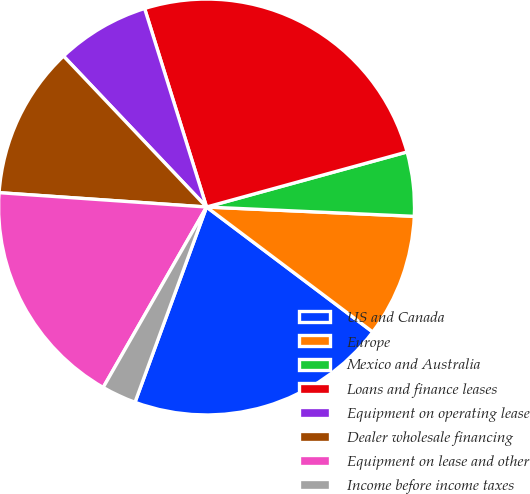Convert chart to OTSL. <chart><loc_0><loc_0><loc_500><loc_500><pie_chart><fcel>US and Canada<fcel>Europe<fcel>Mexico and Australia<fcel>Loans and finance leases<fcel>Equipment on operating lease<fcel>Dealer wholesale financing<fcel>Equipment on lease and other<fcel>Income before income taxes<nl><fcel>20.33%<fcel>9.55%<fcel>4.98%<fcel>25.55%<fcel>7.26%<fcel>11.83%<fcel>17.82%<fcel>2.69%<nl></chart> 